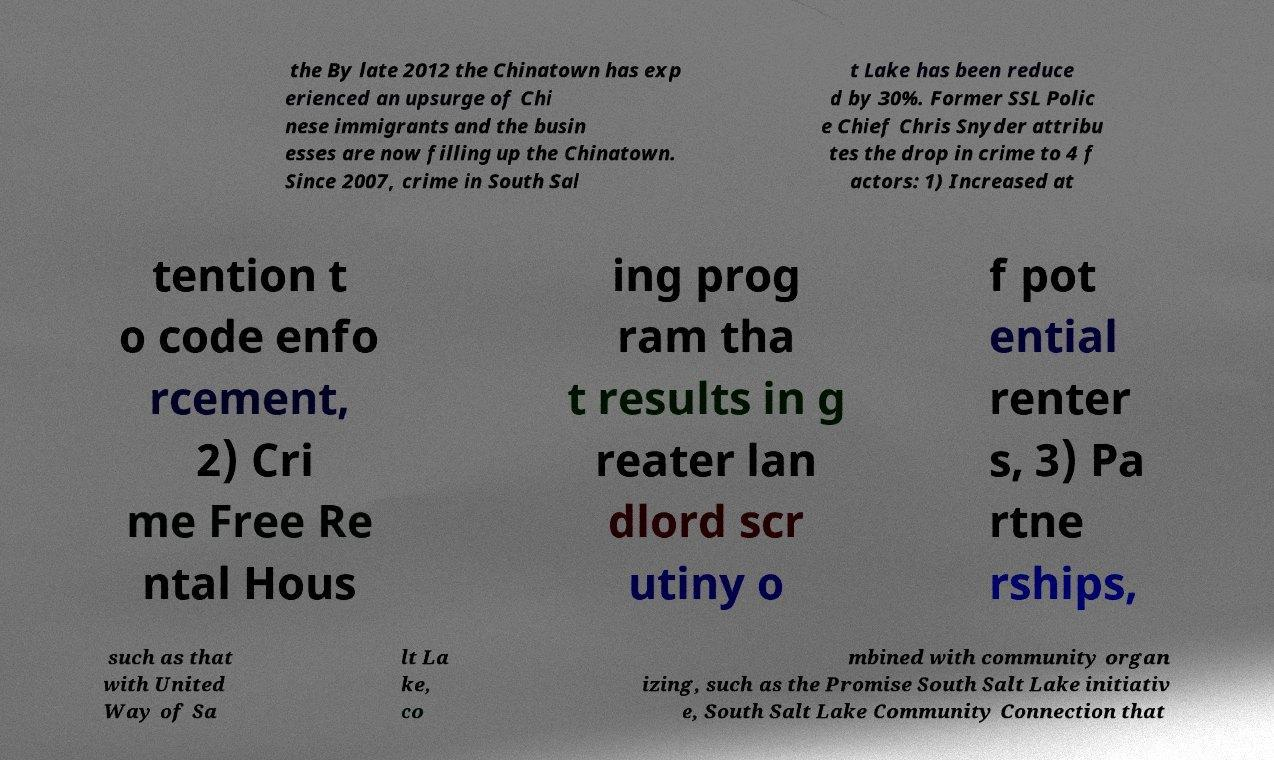What messages or text are displayed in this image? I need them in a readable, typed format. the By late 2012 the Chinatown has exp erienced an upsurge of Chi nese immigrants and the busin esses are now filling up the Chinatown. Since 2007, crime in South Sal t Lake has been reduce d by 30%. Former SSL Polic e Chief Chris Snyder attribu tes the drop in crime to 4 f actors: 1) Increased at tention t o code enfo rcement, 2) Cri me Free Re ntal Hous ing prog ram tha t results in g reater lan dlord scr utiny o f pot ential renter s, 3) Pa rtne rships, such as that with United Way of Sa lt La ke, co mbined with community organ izing, such as the Promise South Salt Lake initiativ e, South Salt Lake Community Connection that 